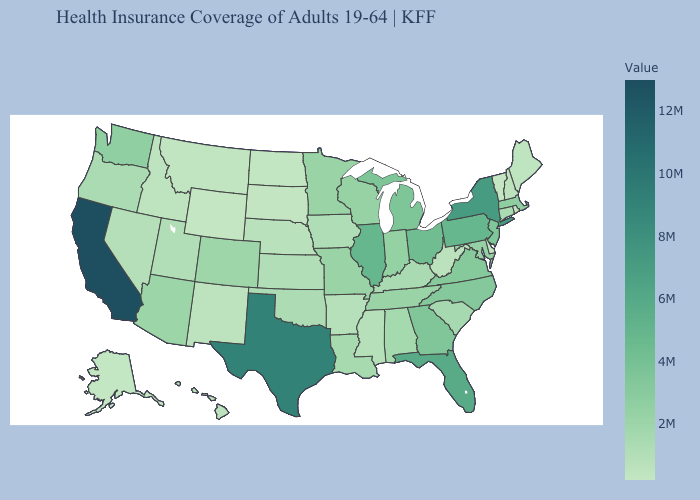Among the states that border Ohio , does Kentucky have the lowest value?
Give a very brief answer. No. Does Connecticut have a higher value than New Jersey?
Quick response, please. No. Among the states that border Louisiana , which have the lowest value?
Write a very short answer. Mississippi. Does California have the highest value in the USA?
Answer briefly. Yes. Which states hav the highest value in the South?
Be succinct. Texas. Does New Mexico have a higher value than Ohio?
Be succinct. No. 